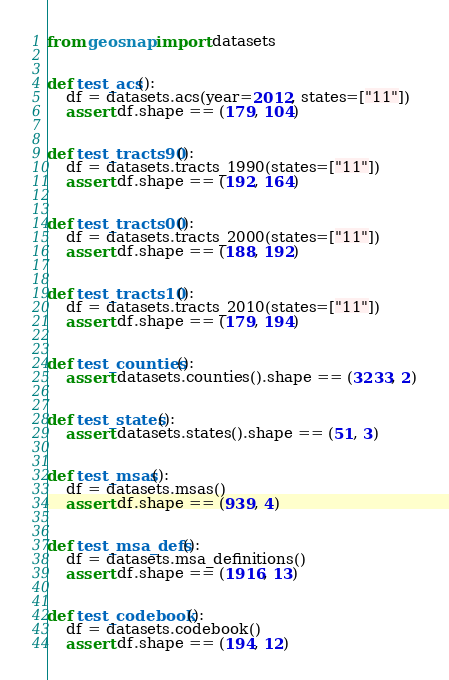Convert code to text. <code><loc_0><loc_0><loc_500><loc_500><_Python_>from geosnap import datasets


def test_acs():
    df = datasets.acs(year=2012, states=["11"])
    assert df.shape == (179, 104)


def test_tracts90():
    df = datasets.tracts_1990(states=["11"])
    assert df.shape == (192, 164)


def test_tracts00():
    df = datasets.tracts_2000(states=["11"])
    assert df.shape == (188, 192)


def test_tracts10():
    df = datasets.tracts_2010(states=["11"])
    assert df.shape == (179, 194)


def test_counties():
    assert datasets.counties().shape == (3233, 2)


def test_states():
    assert datasets.states().shape == (51, 3)


def test_msas():
    df = datasets.msas()
    assert df.shape == (939, 4)


def test_msa_defs():
    df = datasets.msa_definitions()
    assert df.shape == (1916, 13)


def test_codebook():
    df = datasets.codebook()
    assert df.shape == (194, 12)
</code> 